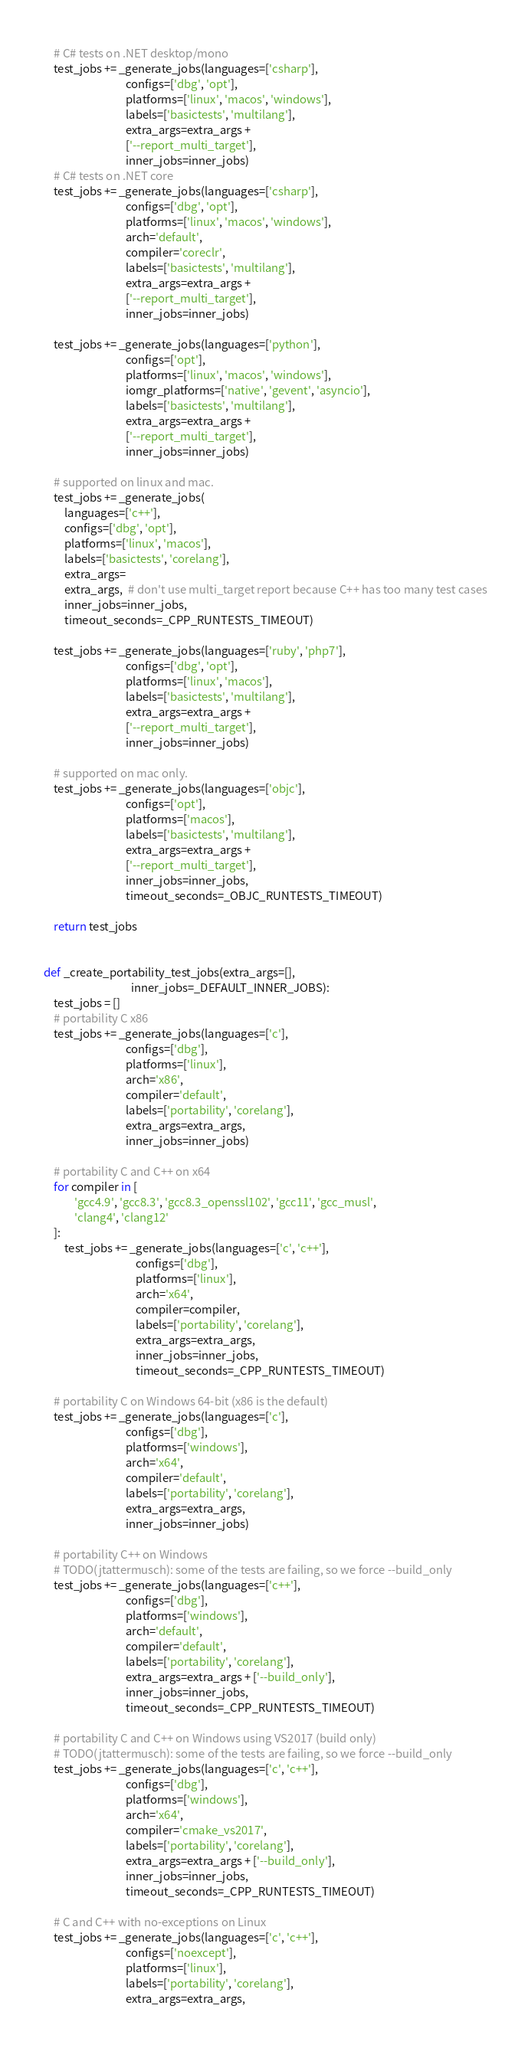Convert code to text. <code><loc_0><loc_0><loc_500><loc_500><_Python_>
    # C# tests on .NET desktop/mono
    test_jobs += _generate_jobs(languages=['csharp'],
                                configs=['dbg', 'opt'],
                                platforms=['linux', 'macos', 'windows'],
                                labels=['basictests', 'multilang'],
                                extra_args=extra_args +
                                ['--report_multi_target'],
                                inner_jobs=inner_jobs)
    # C# tests on .NET core
    test_jobs += _generate_jobs(languages=['csharp'],
                                configs=['dbg', 'opt'],
                                platforms=['linux', 'macos', 'windows'],
                                arch='default',
                                compiler='coreclr',
                                labels=['basictests', 'multilang'],
                                extra_args=extra_args +
                                ['--report_multi_target'],
                                inner_jobs=inner_jobs)

    test_jobs += _generate_jobs(languages=['python'],
                                configs=['opt'],
                                platforms=['linux', 'macos', 'windows'],
                                iomgr_platforms=['native', 'gevent', 'asyncio'],
                                labels=['basictests', 'multilang'],
                                extra_args=extra_args +
                                ['--report_multi_target'],
                                inner_jobs=inner_jobs)

    # supported on linux and mac.
    test_jobs += _generate_jobs(
        languages=['c++'],
        configs=['dbg', 'opt'],
        platforms=['linux', 'macos'],
        labels=['basictests', 'corelang'],
        extra_args=
        extra_args,  # don't use multi_target report because C++ has too many test cases
        inner_jobs=inner_jobs,
        timeout_seconds=_CPP_RUNTESTS_TIMEOUT)

    test_jobs += _generate_jobs(languages=['ruby', 'php7'],
                                configs=['dbg', 'opt'],
                                platforms=['linux', 'macos'],
                                labels=['basictests', 'multilang'],
                                extra_args=extra_args +
                                ['--report_multi_target'],
                                inner_jobs=inner_jobs)

    # supported on mac only.
    test_jobs += _generate_jobs(languages=['objc'],
                                configs=['opt'],
                                platforms=['macos'],
                                labels=['basictests', 'multilang'],
                                extra_args=extra_args +
                                ['--report_multi_target'],
                                inner_jobs=inner_jobs,
                                timeout_seconds=_OBJC_RUNTESTS_TIMEOUT)

    return test_jobs


def _create_portability_test_jobs(extra_args=[],
                                  inner_jobs=_DEFAULT_INNER_JOBS):
    test_jobs = []
    # portability C x86
    test_jobs += _generate_jobs(languages=['c'],
                                configs=['dbg'],
                                platforms=['linux'],
                                arch='x86',
                                compiler='default',
                                labels=['portability', 'corelang'],
                                extra_args=extra_args,
                                inner_jobs=inner_jobs)

    # portability C and C++ on x64
    for compiler in [
            'gcc4.9', 'gcc8.3', 'gcc8.3_openssl102', 'gcc11', 'gcc_musl',
            'clang4', 'clang12'
    ]:
        test_jobs += _generate_jobs(languages=['c', 'c++'],
                                    configs=['dbg'],
                                    platforms=['linux'],
                                    arch='x64',
                                    compiler=compiler,
                                    labels=['portability', 'corelang'],
                                    extra_args=extra_args,
                                    inner_jobs=inner_jobs,
                                    timeout_seconds=_CPP_RUNTESTS_TIMEOUT)

    # portability C on Windows 64-bit (x86 is the default)
    test_jobs += _generate_jobs(languages=['c'],
                                configs=['dbg'],
                                platforms=['windows'],
                                arch='x64',
                                compiler='default',
                                labels=['portability', 'corelang'],
                                extra_args=extra_args,
                                inner_jobs=inner_jobs)

    # portability C++ on Windows
    # TODO(jtattermusch): some of the tests are failing, so we force --build_only
    test_jobs += _generate_jobs(languages=['c++'],
                                configs=['dbg'],
                                platforms=['windows'],
                                arch='default',
                                compiler='default',
                                labels=['portability', 'corelang'],
                                extra_args=extra_args + ['--build_only'],
                                inner_jobs=inner_jobs,
                                timeout_seconds=_CPP_RUNTESTS_TIMEOUT)

    # portability C and C++ on Windows using VS2017 (build only)
    # TODO(jtattermusch): some of the tests are failing, so we force --build_only
    test_jobs += _generate_jobs(languages=['c', 'c++'],
                                configs=['dbg'],
                                platforms=['windows'],
                                arch='x64',
                                compiler='cmake_vs2017',
                                labels=['portability', 'corelang'],
                                extra_args=extra_args + ['--build_only'],
                                inner_jobs=inner_jobs,
                                timeout_seconds=_CPP_RUNTESTS_TIMEOUT)

    # C and C++ with no-exceptions on Linux
    test_jobs += _generate_jobs(languages=['c', 'c++'],
                                configs=['noexcept'],
                                platforms=['linux'],
                                labels=['portability', 'corelang'],
                                extra_args=extra_args,</code> 